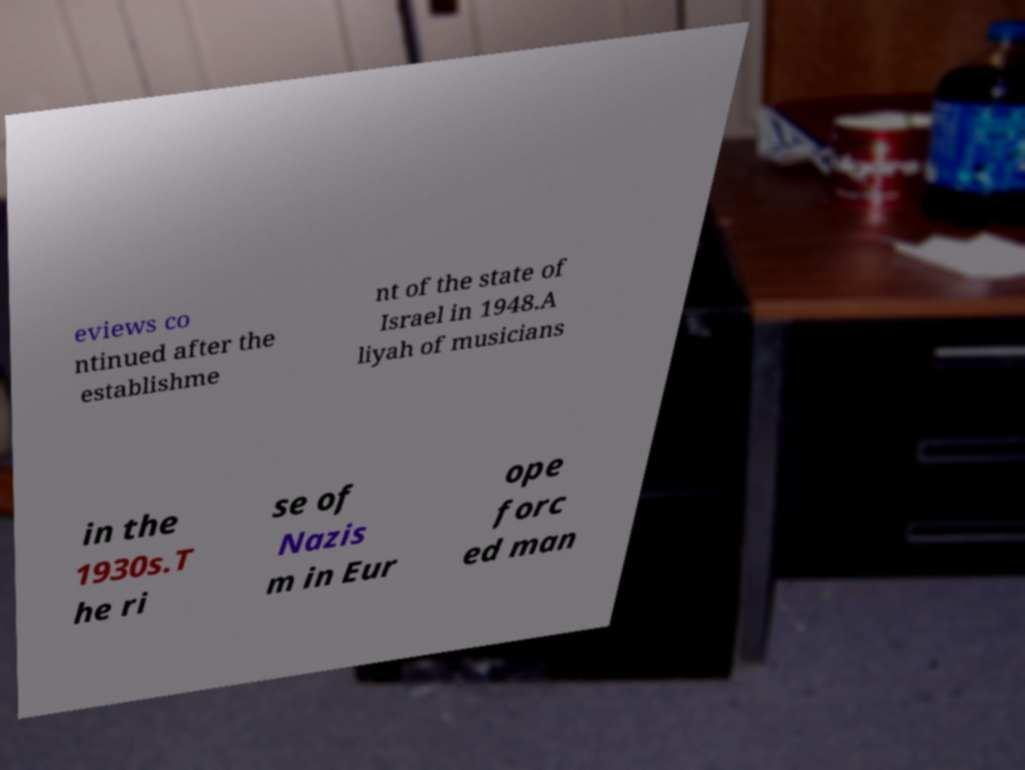Could you extract and type out the text from this image? eviews co ntinued after the establishme nt of the state of Israel in 1948.A liyah of musicians in the 1930s.T he ri se of Nazis m in Eur ope forc ed man 